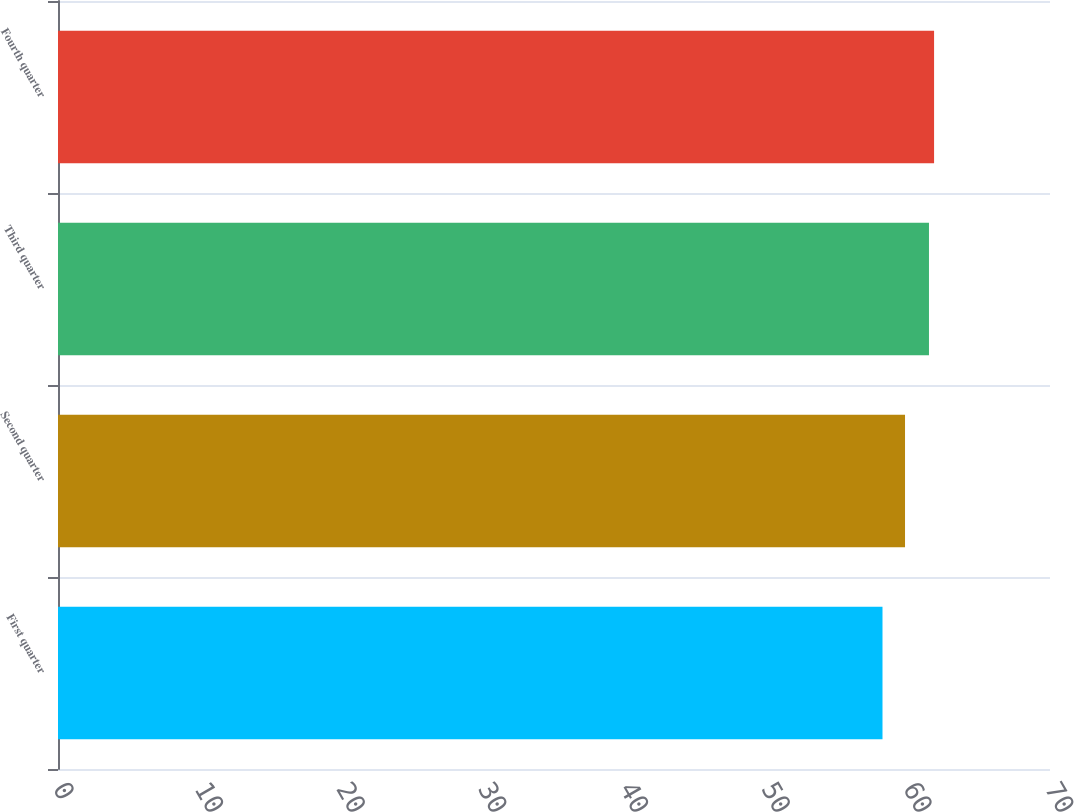Convert chart. <chart><loc_0><loc_0><loc_500><loc_500><bar_chart><fcel>First quarter<fcel>Second quarter<fcel>Third quarter<fcel>Fourth quarter<nl><fcel>58.18<fcel>59.77<fcel>61.46<fcel>61.82<nl></chart> 